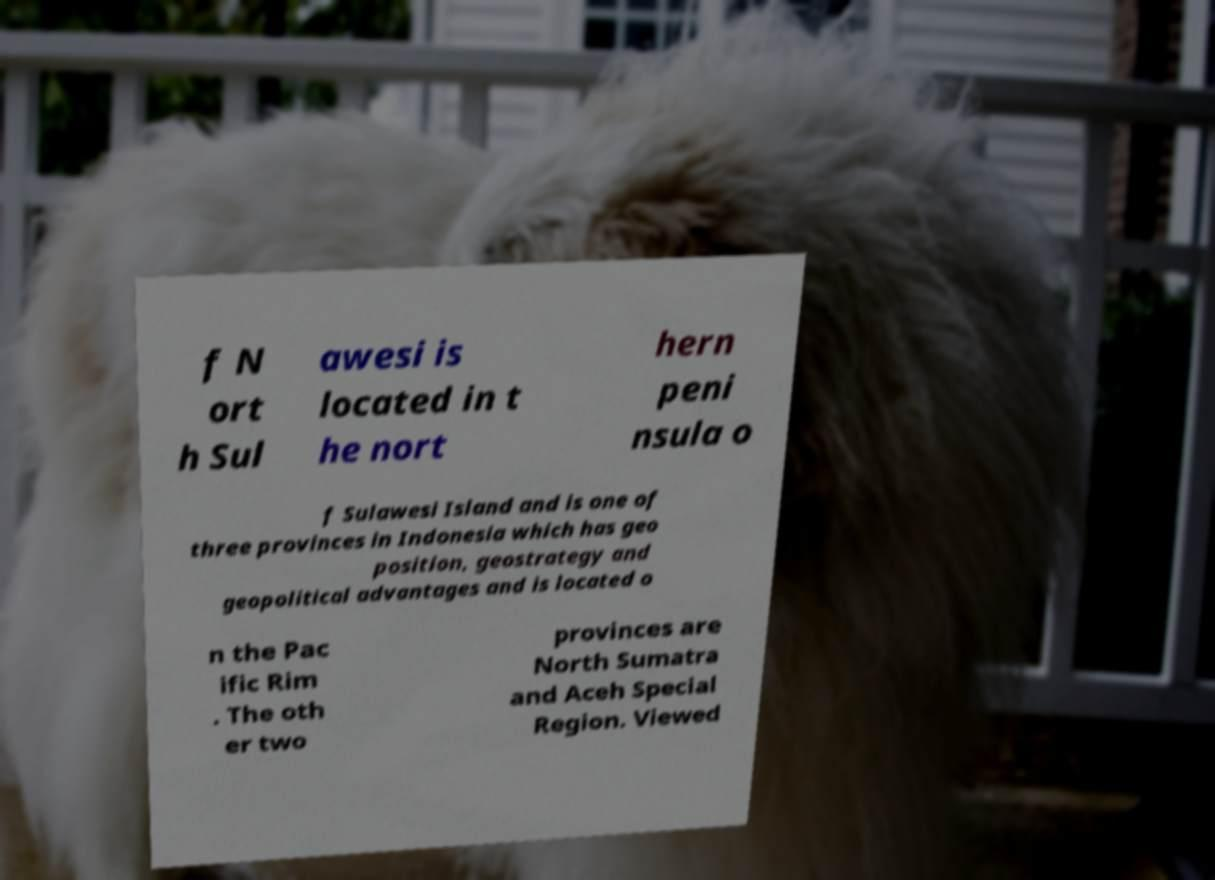Can you read and provide the text displayed in the image?This photo seems to have some interesting text. Can you extract and type it out for me? f N ort h Sul awesi is located in t he nort hern peni nsula o f Sulawesi Island and is one of three provinces in Indonesia which has geo position, geostrategy and geopolitical advantages and is located o n the Pac ific Rim . The oth er two provinces are North Sumatra and Aceh Special Region. Viewed 